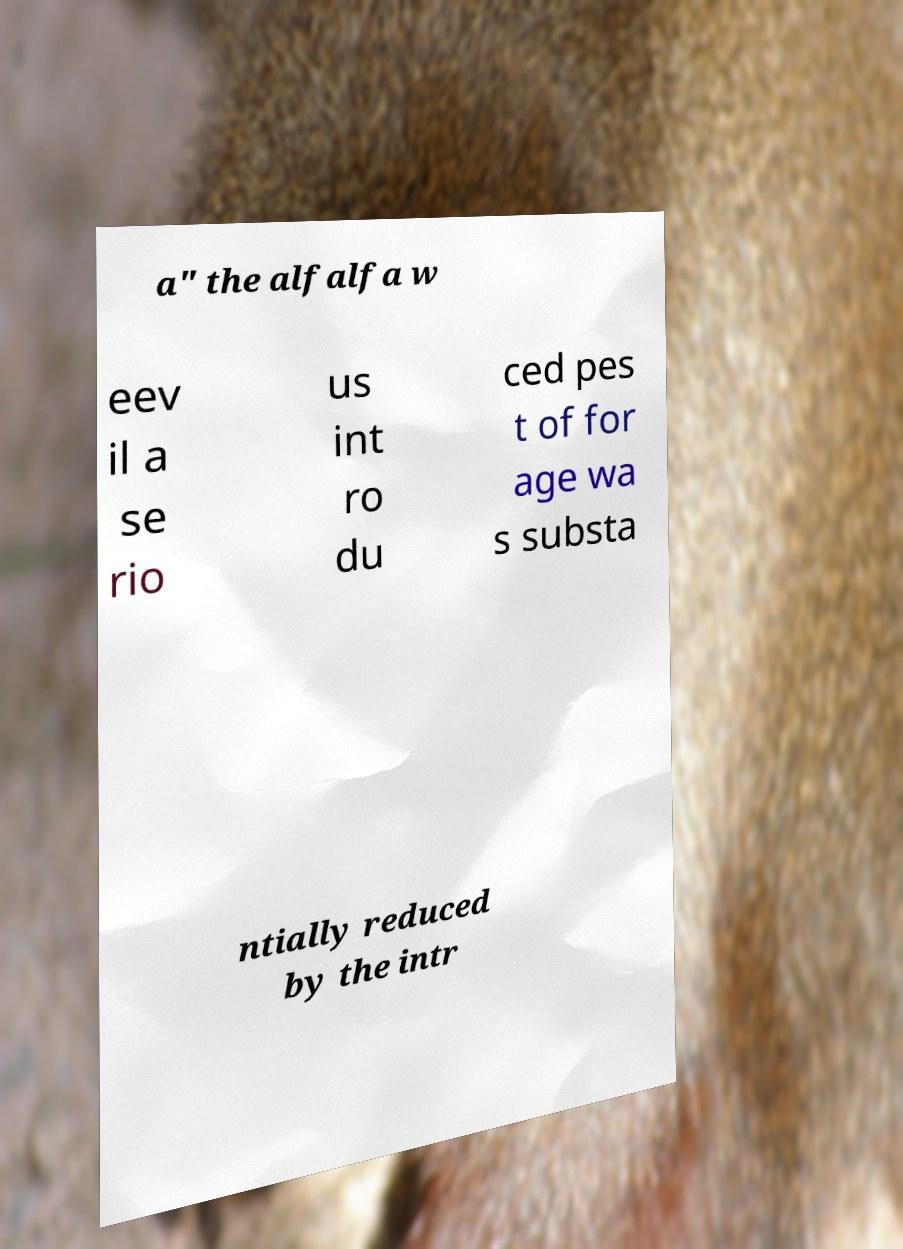Could you assist in decoding the text presented in this image and type it out clearly? a" the alfalfa w eev il a se rio us int ro du ced pes t of for age wa s substa ntially reduced by the intr 